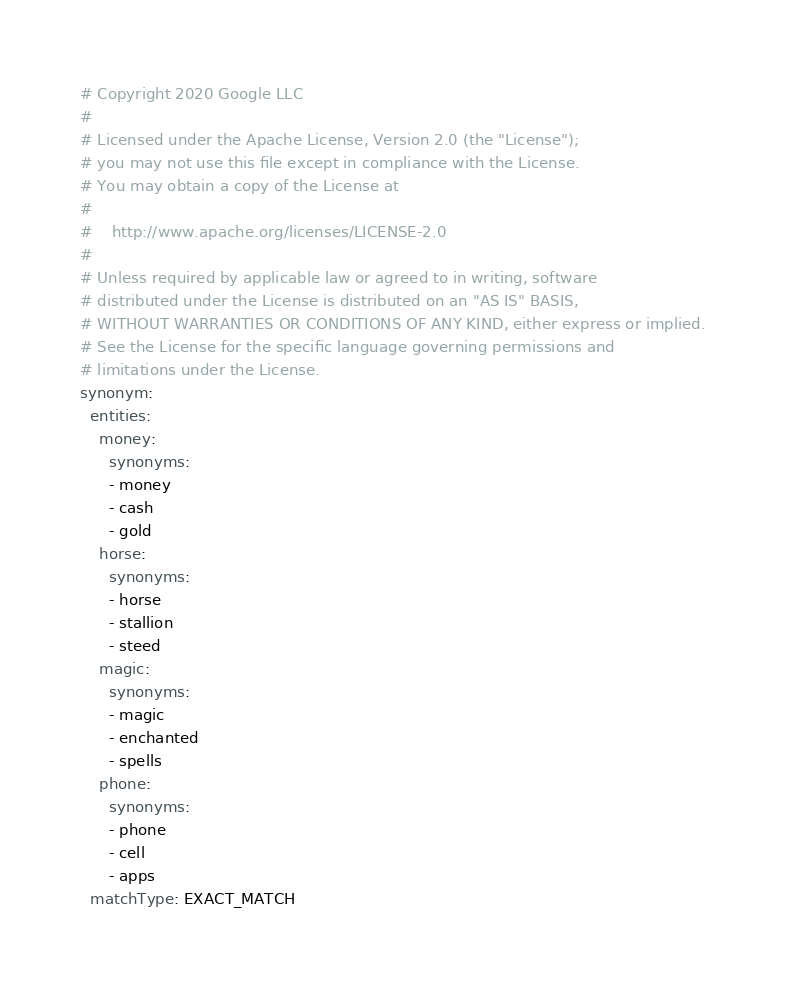<code> <loc_0><loc_0><loc_500><loc_500><_YAML_># Copyright 2020 Google LLC
#
# Licensed under the Apache License, Version 2.0 (the "License");
# you may not use this file except in compliance with the License.
# You may obtain a copy of the License at
#
#    http://www.apache.org/licenses/LICENSE-2.0
#
# Unless required by applicable law or agreed to in writing, software
# distributed under the License is distributed on an "AS IS" BASIS,
# WITHOUT WARRANTIES OR CONDITIONS OF ANY KIND, either express or implied.
# See the License for the specific language governing permissions and
# limitations under the License.
synonym:
  entities:
    money:
      synonyms:
      - money
      - cash
      - gold
    horse:
      synonyms:
      - horse
      - stallion
      - steed
    magic:
      synonyms:
      - magic
      - enchanted
      - spells
    phone:
      synonyms:
      - phone
      - cell
      - apps
  matchType: EXACT_MATCH
</code> 